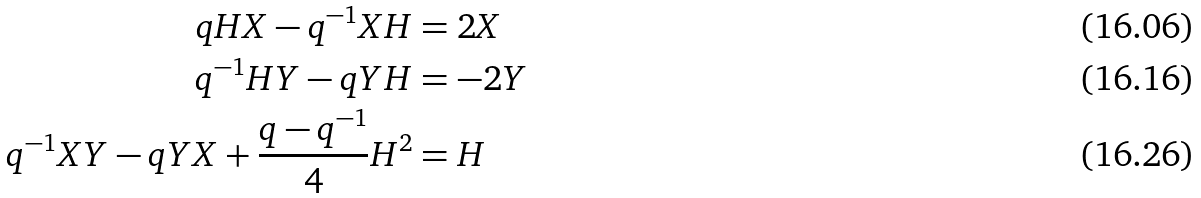Convert formula to latex. <formula><loc_0><loc_0><loc_500><loc_500>q H X - q ^ { - 1 } X H & = 2 X \\ q ^ { - 1 } H Y - q Y H & = - 2 Y \\ q ^ { - 1 } X Y - q Y X + \frac { q - q ^ { - 1 } } { 4 } H ^ { 2 } & = H</formula> 